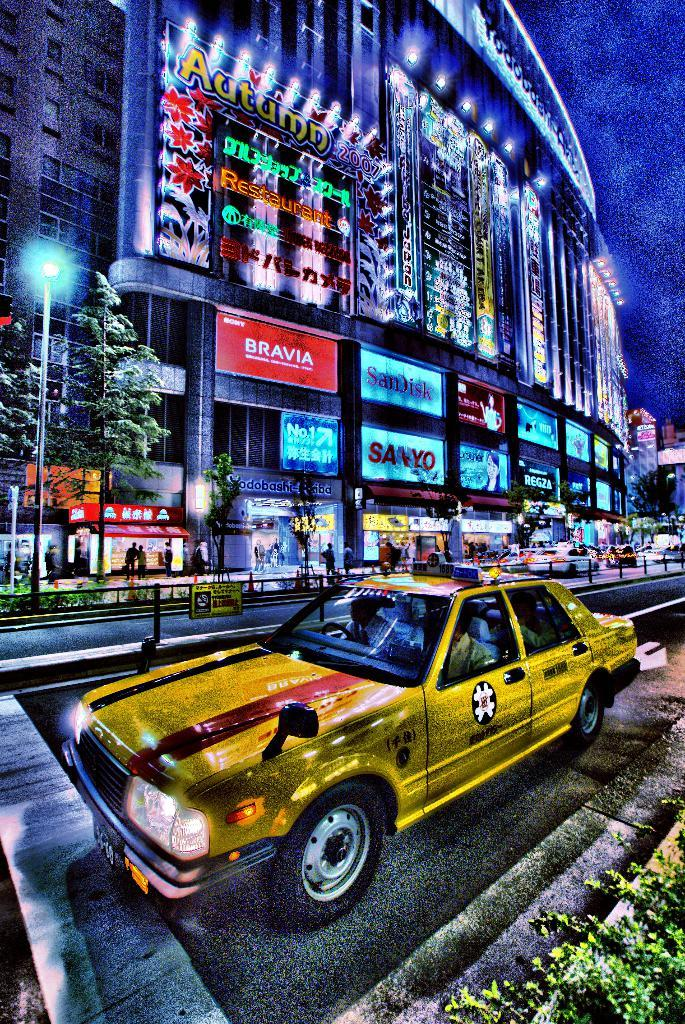Provide a one-sentence caption for the provided image. A yellow car parked on a street in front of a city building with signs lit up on it such as Bravia, SanDisk, Sanyo along with many others. 